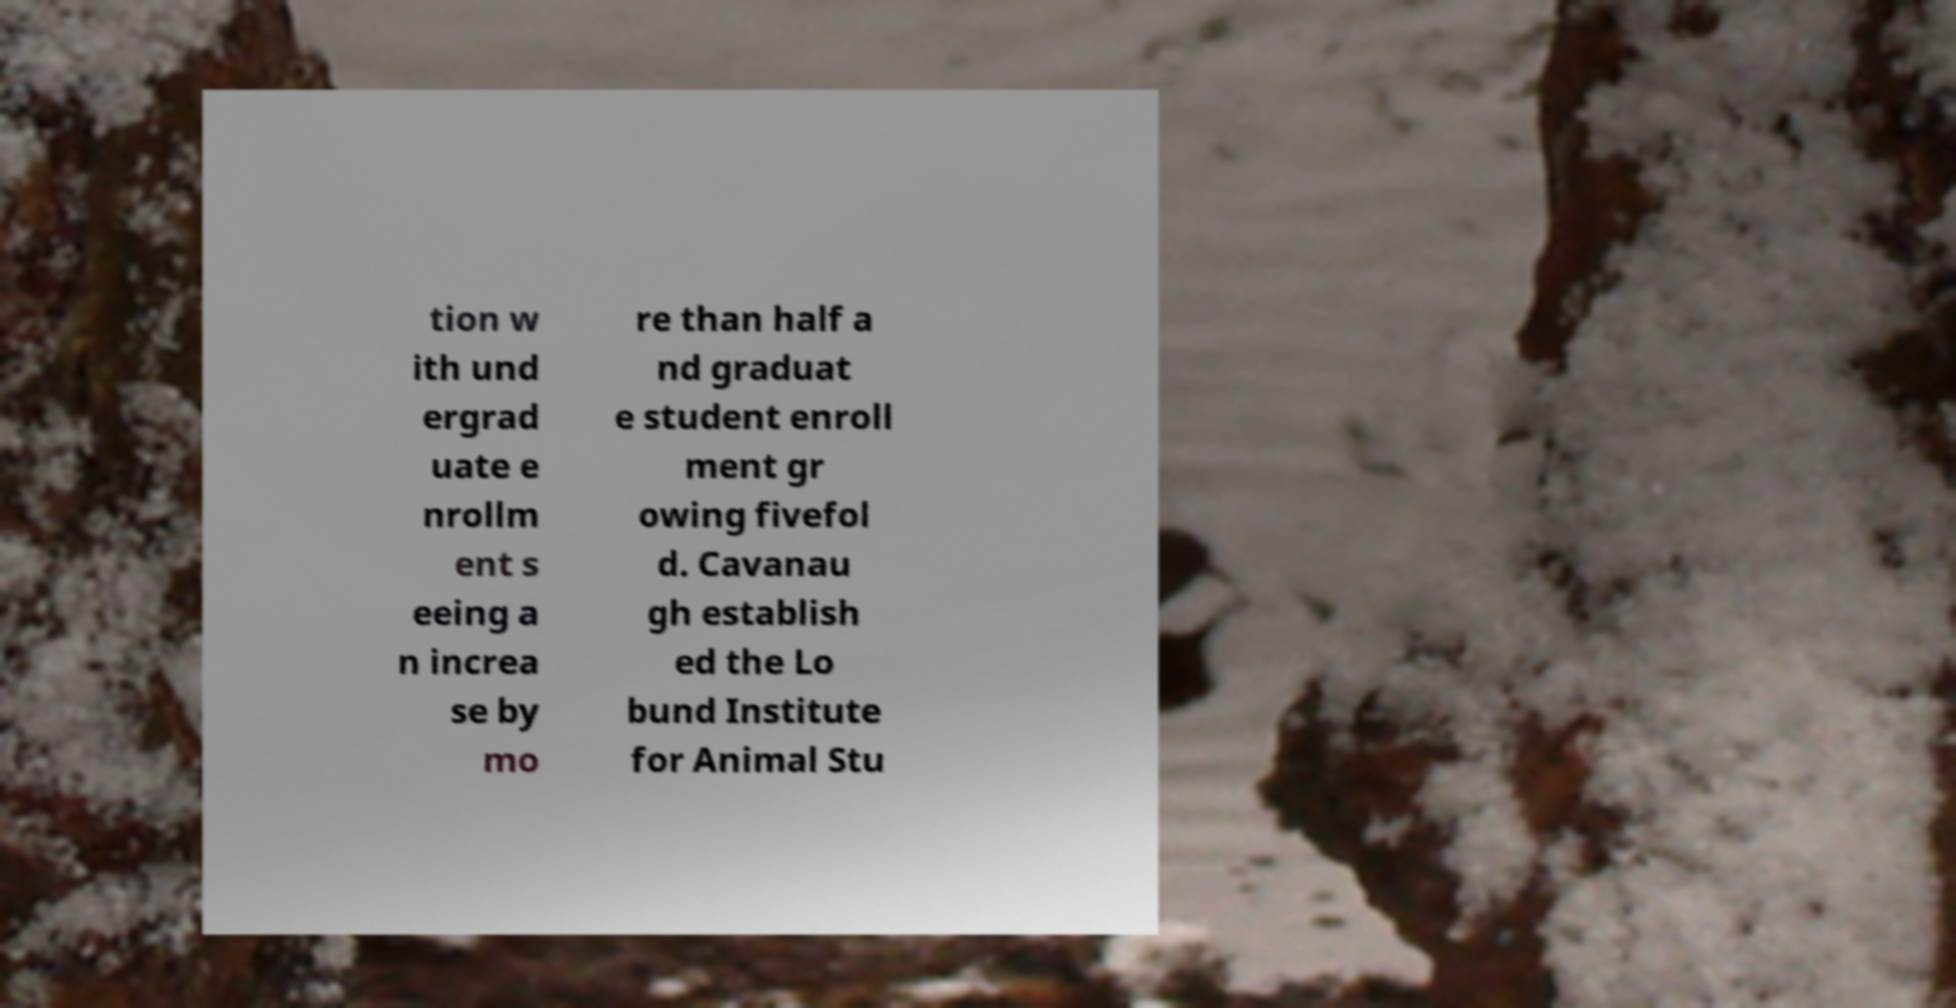Please identify and transcribe the text found in this image. tion w ith und ergrad uate e nrollm ent s eeing a n increa se by mo re than half a nd graduat e student enroll ment gr owing fivefol d. Cavanau gh establish ed the Lo bund Institute for Animal Stu 